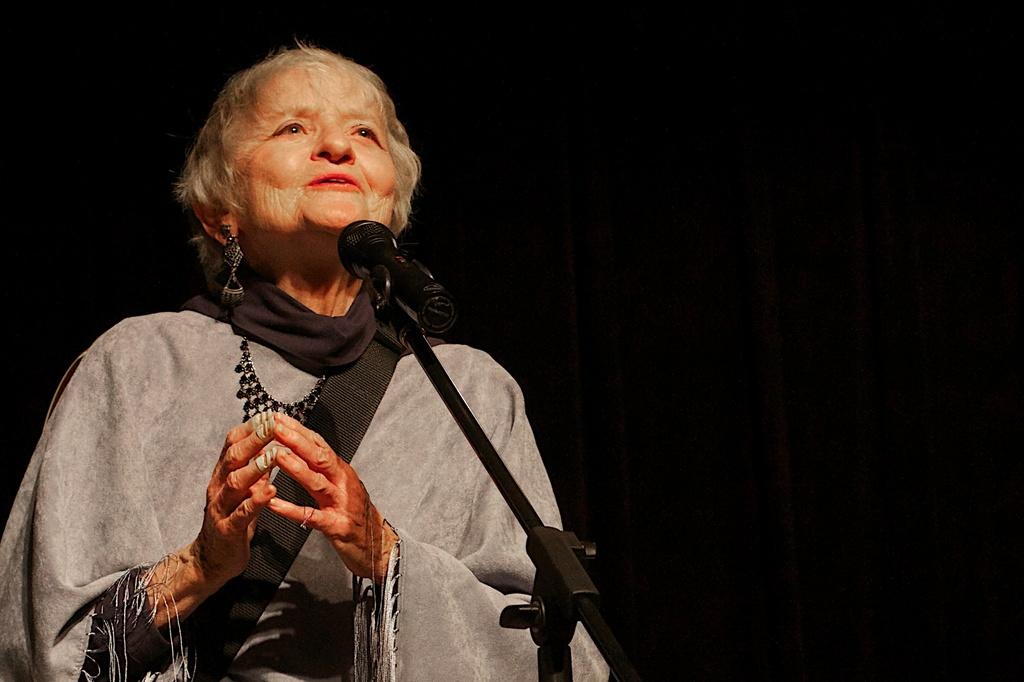Who is the main subject in the image? There is a woman in the image. What is the woman doing in the image? The woman is standing in front of a microphone. What type of bells can be heard ringing in the image? There are no bells present in the image, and therefore no sound can be heard. 